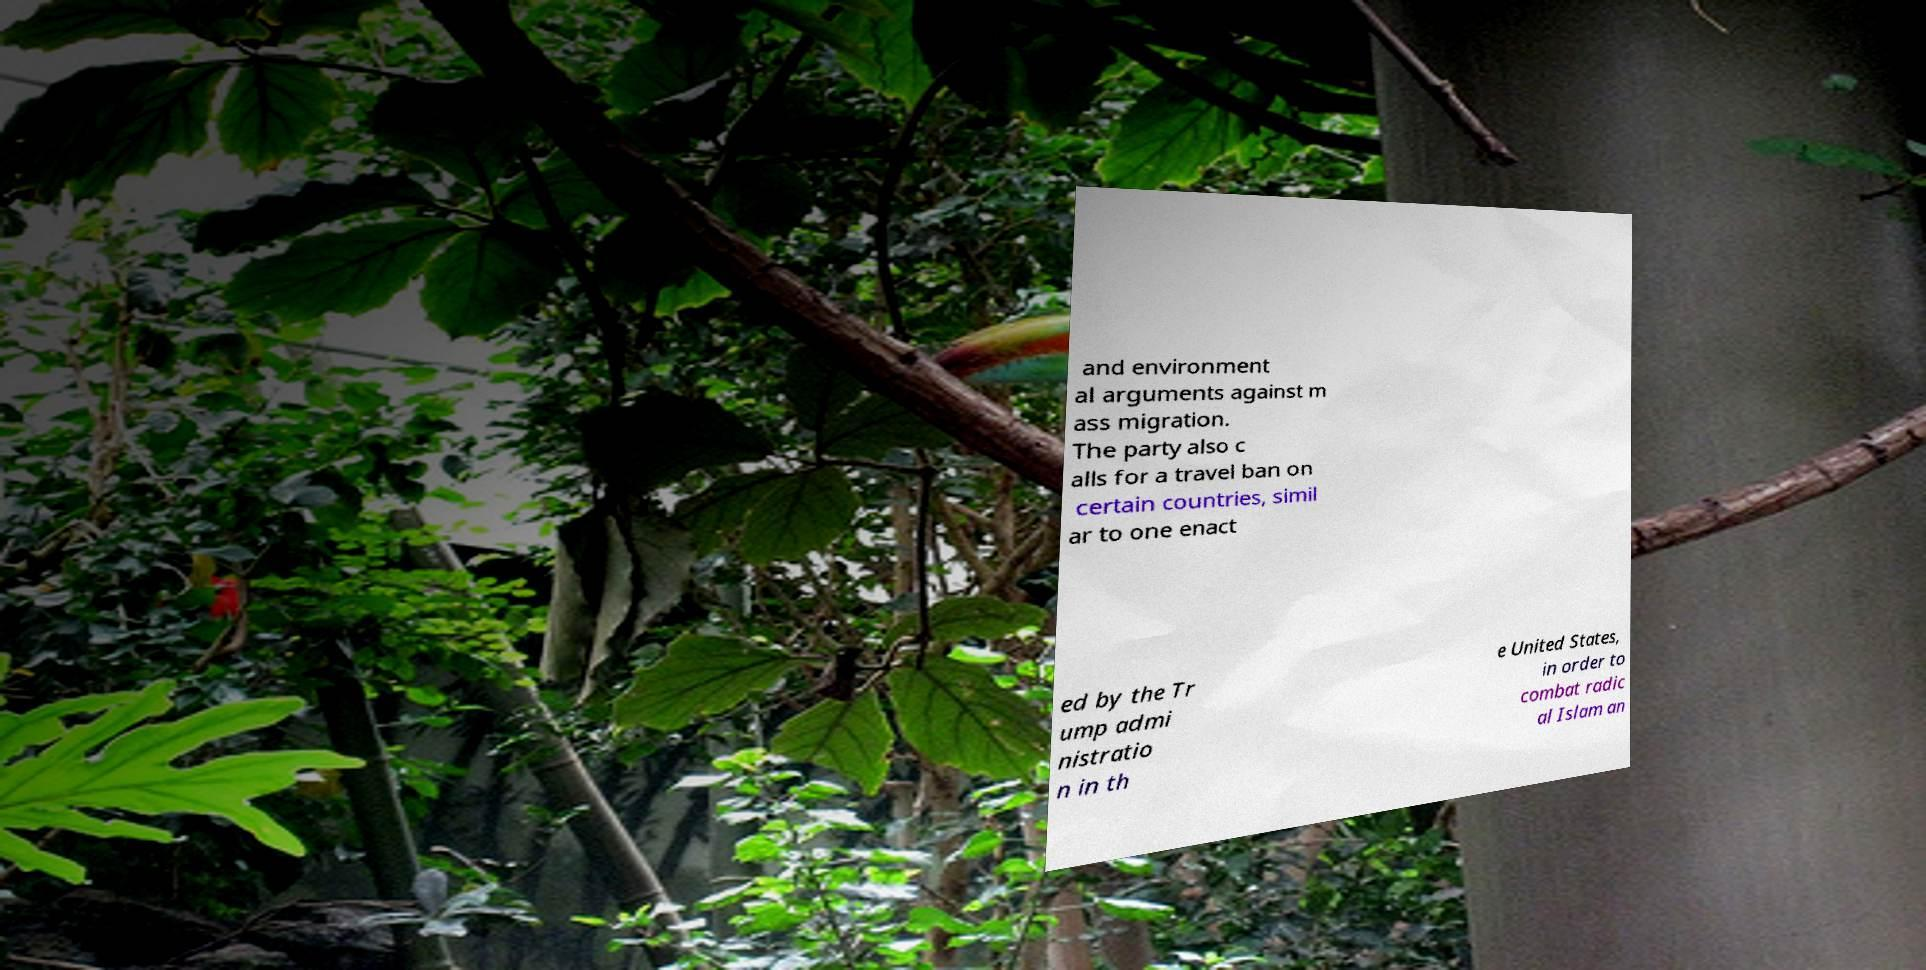Can you accurately transcribe the text from the provided image for me? and environment al arguments against m ass migration. The party also c alls for a travel ban on certain countries, simil ar to one enact ed by the Tr ump admi nistratio n in th e United States, in order to combat radic al Islam an 